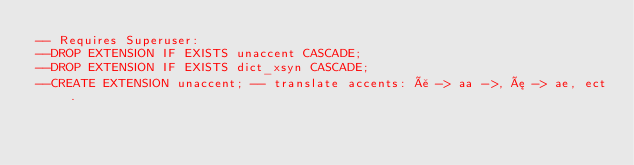Convert code to text. <code><loc_0><loc_0><loc_500><loc_500><_SQL_>-- Requires Superuser:
--DROP EXTENSION IF EXISTS unaccent CASCADE;
--DROP EXTENSION IF EXISTS dict_xsyn CASCADE;
--CREATE EXTENSION unaccent; -- translate accents: å -> aa ->, æ -> ae, ect.</code> 